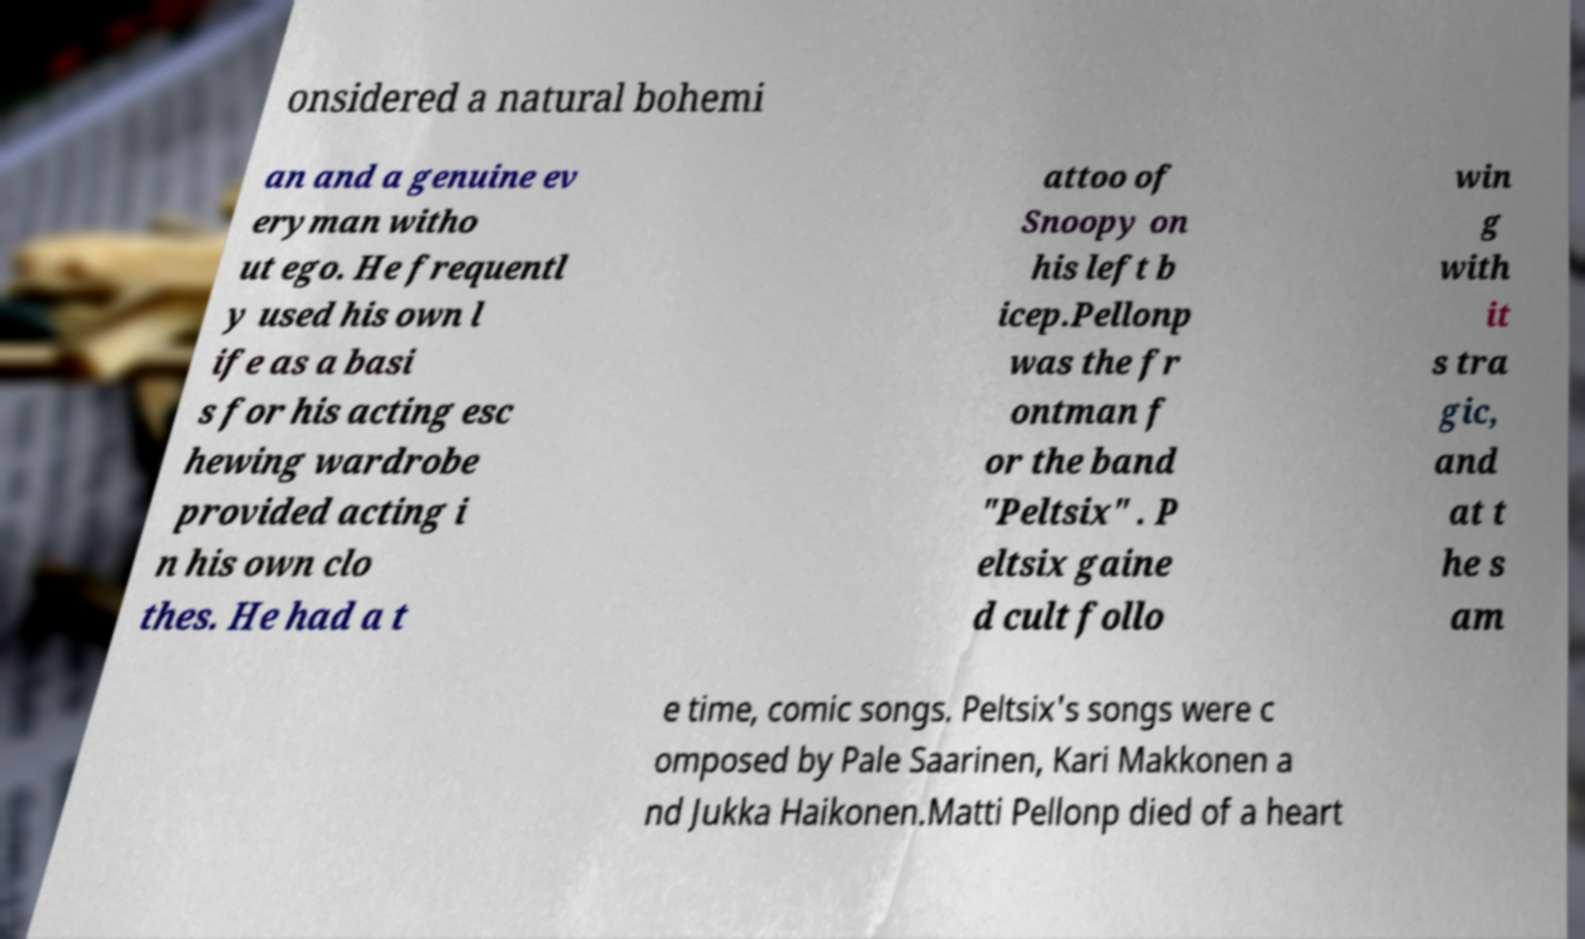What messages or text are displayed in this image? I need them in a readable, typed format. onsidered a natural bohemi an and a genuine ev eryman witho ut ego. He frequentl y used his own l ife as a basi s for his acting esc hewing wardrobe provided acting i n his own clo thes. He had a t attoo of Snoopy on his left b icep.Pellonp was the fr ontman f or the band "Peltsix" . P eltsix gaine d cult follo win g with it s tra gic, and at t he s am e time, comic songs. Peltsix's songs were c omposed by Pale Saarinen, Kari Makkonen a nd Jukka Haikonen.Matti Pellonp died of a heart 